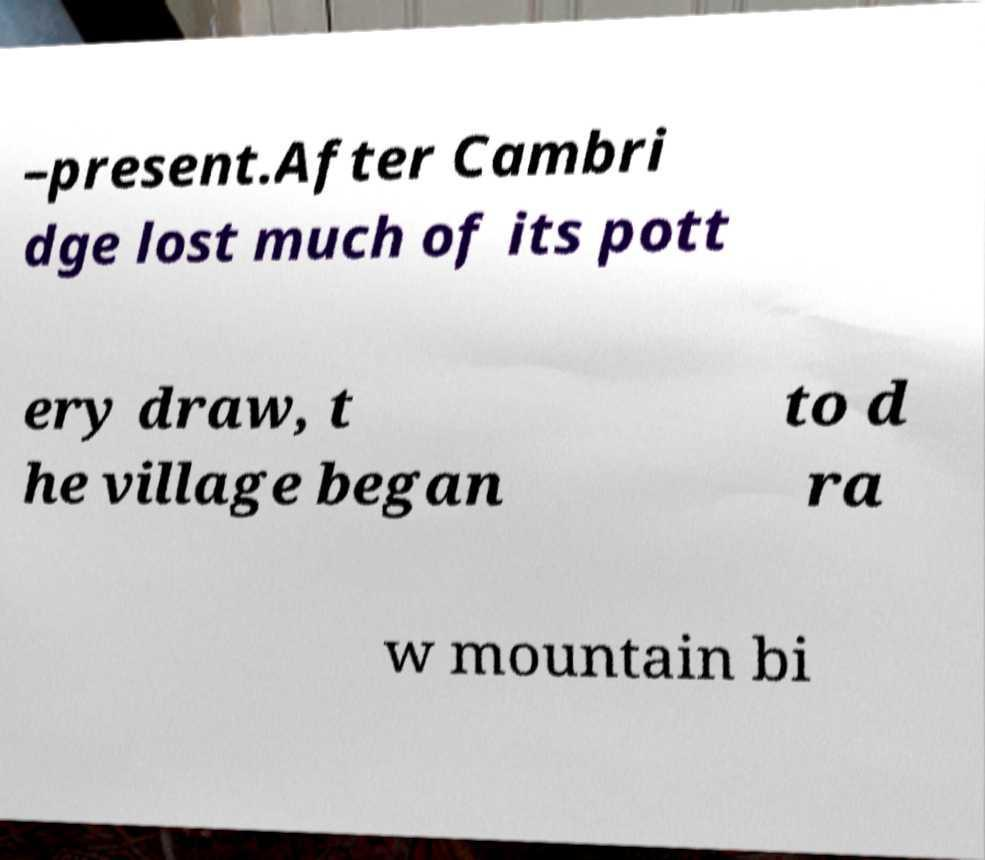For documentation purposes, I need the text within this image transcribed. Could you provide that? –present.After Cambri dge lost much of its pott ery draw, t he village began to d ra w mountain bi 